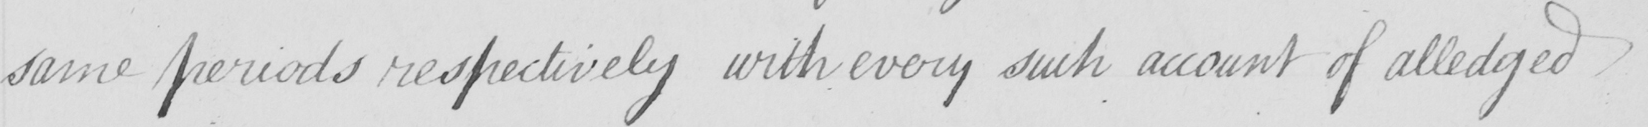Please provide the text content of this handwritten line. same periods respectively with every such account of alledged 